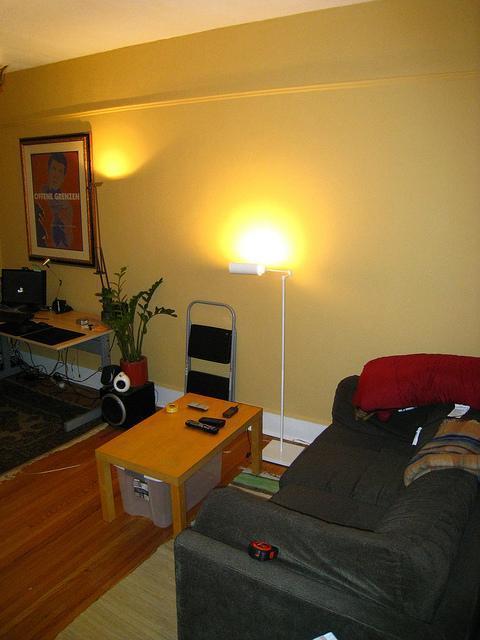How many horses are in the picture?
Give a very brief answer. 0. 